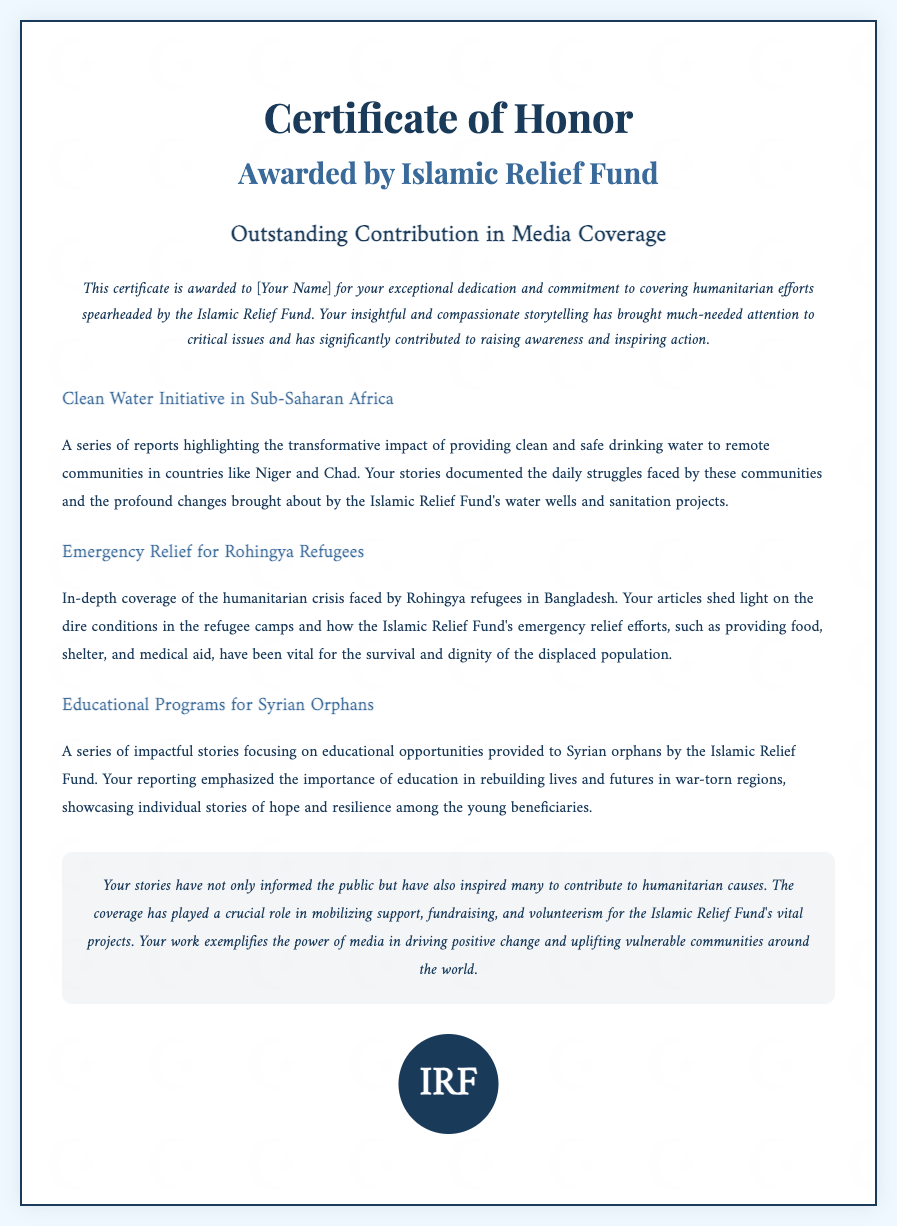What is the title of the certificate? The title of the certificate states, "Certificate of Honor."
Answer: Certificate of Honor Who awarded the certificate? The certificate is awarded by the "Islamic Relief Fund."
Answer: Islamic Relief Fund What is the main purpose of the award? The main purpose of the award is for "Outstanding Contribution in Media Coverage."
Answer: Outstanding Contribution in Media Coverage How many projects are highlighted in the certificate? The document mentions "three" projects as highlighted stories.
Answer: three What initiative focuses on providing clean water? The initiative referred to in the document is the "Clean Water Initiative in Sub-Saharan Africa."
Answer: Clean Water Initiative in Sub-Saharan Africa Which refugee crisis is covered in the certificate? The certificate covers the "Emergency Relief for Rohingya Refugees."
Answer: Emergency Relief for Rohingya Refugees What impact did the recipient's stories have? The recipient's stories inspired "humanitarian causes" and mobilized support.
Answer: humanitarian causes What educational opportunity is mentioned in the projects? The document mentions "Educational Programs for Syrian Orphans."
Answer: Educational Programs for Syrian Orphans What does the seal on the certificate represent? The seal on the certificate represents the initials "IRF."
Answer: IRF 